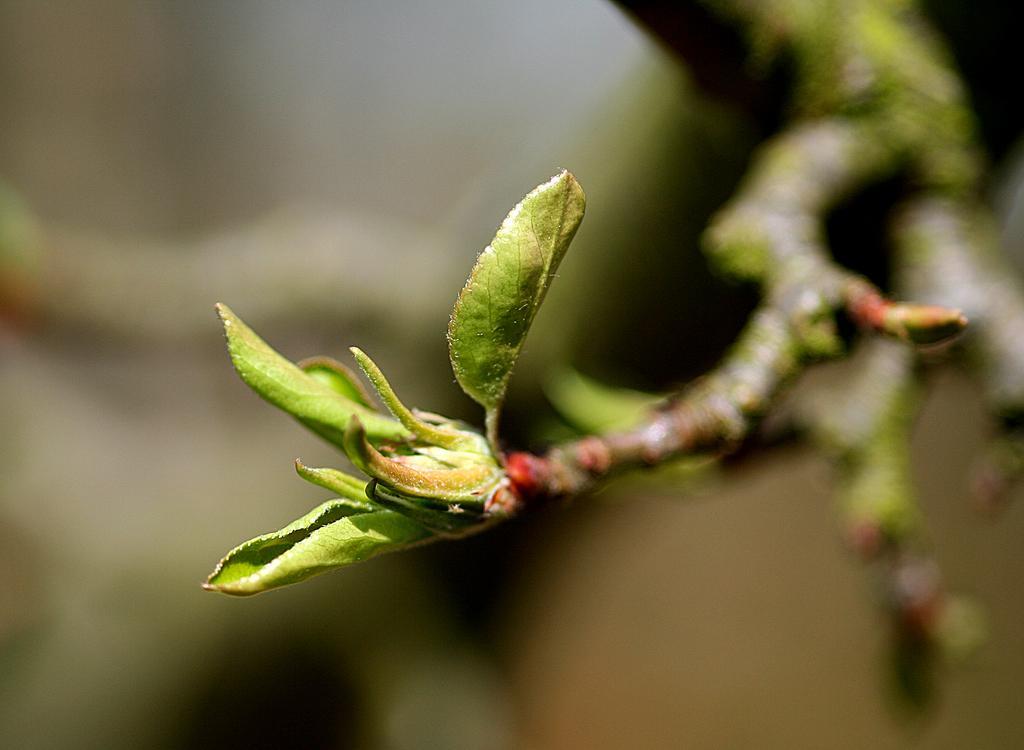How would you summarize this image in a sentence or two? In this picture I can see the leaves and the stems. I see that it is blurred in the background. 